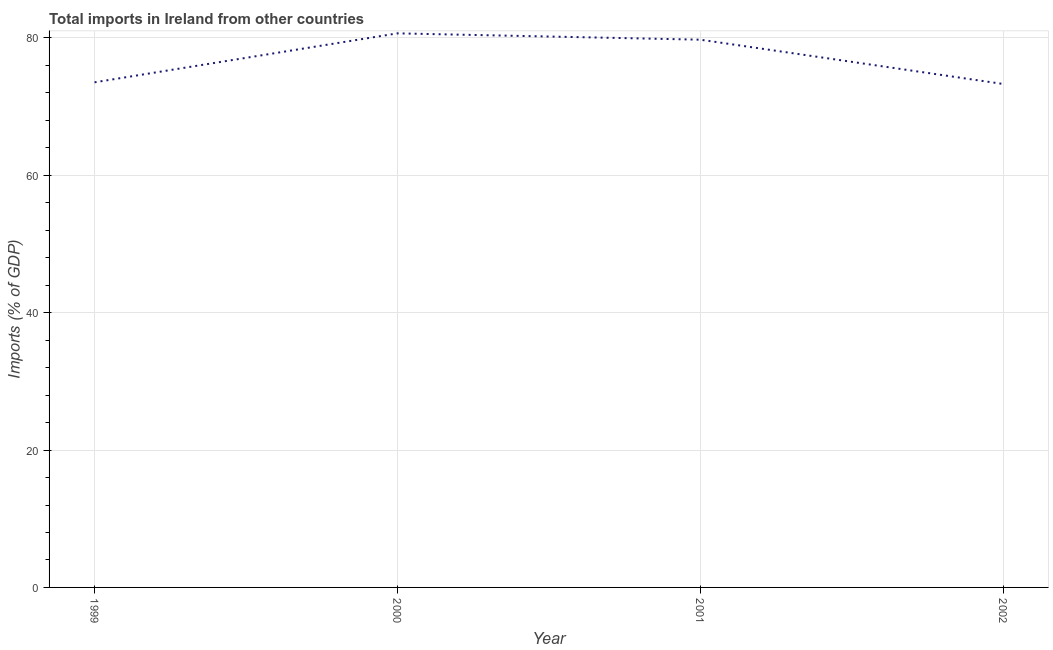What is the total imports in 2002?
Provide a short and direct response. 73.3. Across all years, what is the maximum total imports?
Ensure brevity in your answer.  80.67. Across all years, what is the minimum total imports?
Keep it short and to the point. 73.3. What is the sum of the total imports?
Keep it short and to the point. 307.25. What is the difference between the total imports in 2000 and 2002?
Provide a succinct answer. 7.37. What is the average total imports per year?
Keep it short and to the point. 76.81. What is the median total imports?
Provide a short and direct response. 76.64. In how many years, is the total imports greater than 72 %?
Ensure brevity in your answer.  4. What is the ratio of the total imports in 2000 to that in 2001?
Give a very brief answer. 1.01. What is the difference between the highest and the second highest total imports?
Ensure brevity in your answer.  0.92. Is the sum of the total imports in 2000 and 2001 greater than the maximum total imports across all years?
Your response must be concise. Yes. What is the difference between the highest and the lowest total imports?
Your answer should be very brief. 7.37. Does the graph contain any zero values?
Keep it short and to the point. No. What is the title of the graph?
Your response must be concise. Total imports in Ireland from other countries. What is the label or title of the Y-axis?
Offer a terse response. Imports (% of GDP). What is the Imports (% of GDP) of 1999?
Give a very brief answer. 73.54. What is the Imports (% of GDP) of 2000?
Your answer should be compact. 80.67. What is the Imports (% of GDP) in 2001?
Offer a terse response. 79.74. What is the Imports (% of GDP) in 2002?
Your answer should be compact. 73.3. What is the difference between the Imports (% of GDP) in 1999 and 2000?
Your answer should be very brief. -7.13. What is the difference between the Imports (% of GDP) in 1999 and 2001?
Your response must be concise. -6.21. What is the difference between the Imports (% of GDP) in 1999 and 2002?
Offer a very short reply. 0.24. What is the difference between the Imports (% of GDP) in 2000 and 2001?
Offer a very short reply. 0.92. What is the difference between the Imports (% of GDP) in 2000 and 2002?
Offer a terse response. 7.37. What is the difference between the Imports (% of GDP) in 2001 and 2002?
Ensure brevity in your answer.  6.45. What is the ratio of the Imports (% of GDP) in 1999 to that in 2000?
Your answer should be compact. 0.91. What is the ratio of the Imports (% of GDP) in 1999 to that in 2001?
Give a very brief answer. 0.92. What is the ratio of the Imports (% of GDP) in 1999 to that in 2002?
Ensure brevity in your answer.  1. What is the ratio of the Imports (% of GDP) in 2000 to that in 2002?
Your response must be concise. 1.1. What is the ratio of the Imports (% of GDP) in 2001 to that in 2002?
Ensure brevity in your answer.  1.09. 